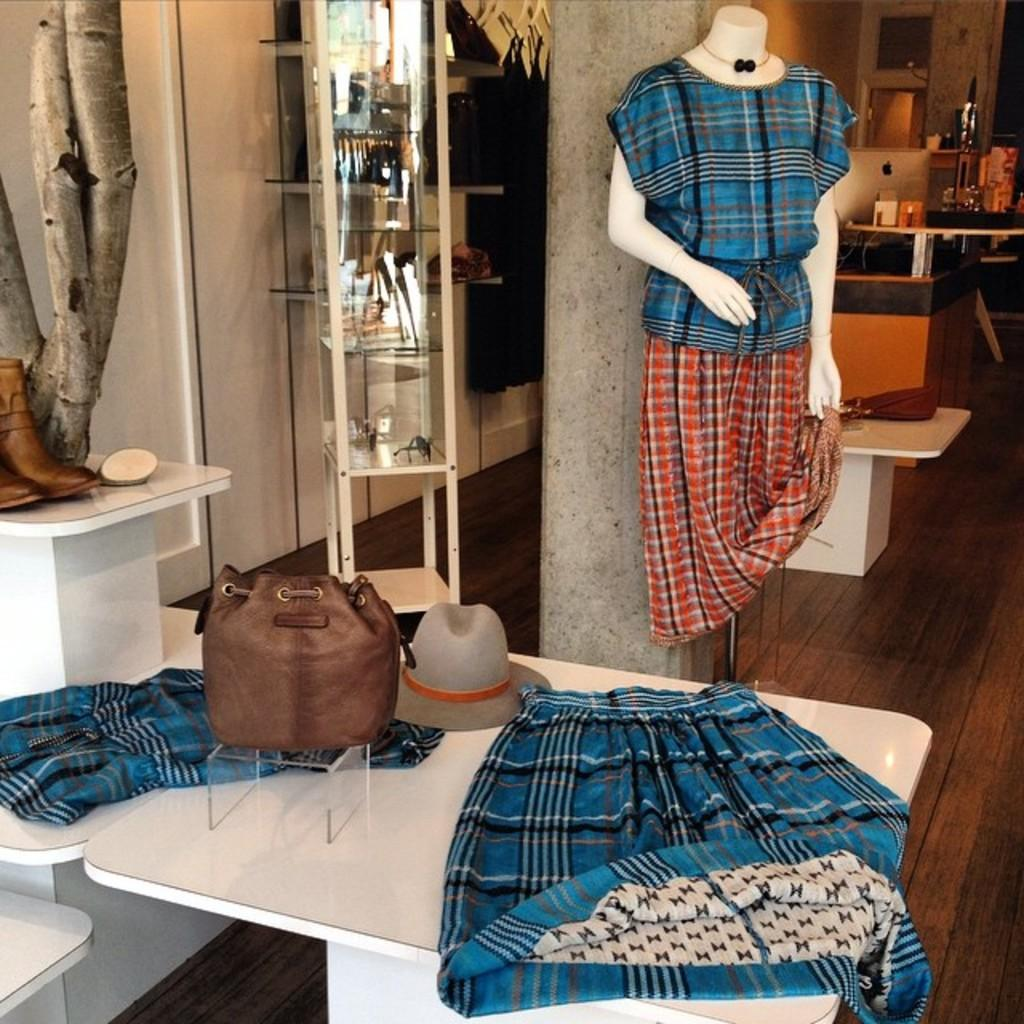What items are placed on the table in the image? There are clothes on the table in the image. What type of accessory is visible in the image? There is a hat in the image. What other personal item can be seen in the image? There is a handbag in the image. What type of footwear is present in the image? There is a shoe in the image. What type of oatmeal is being served in the image? There is no oatmeal present in the image. How many geese are visible in the image? There are no geese visible in the image. 